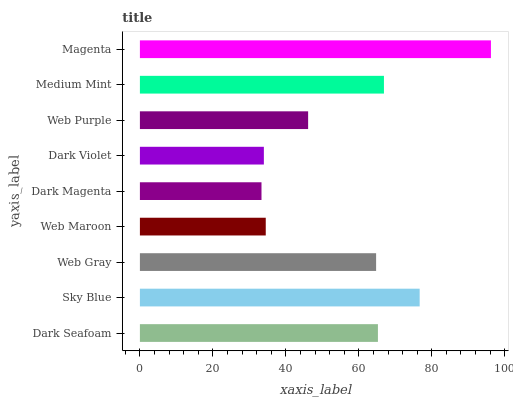Is Dark Magenta the minimum?
Answer yes or no. Yes. Is Magenta the maximum?
Answer yes or no. Yes. Is Sky Blue the minimum?
Answer yes or no. No. Is Sky Blue the maximum?
Answer yes or no. No. Is Sky Blue greater than Dark Seafoam?
Answer yes or no. Yes. Is Dark Seafoam less than Sky Blue?
Answer yes or no. Yes. Is Dark Seafoam greater than Sky Blue?
Answer yes or no. No. Is Sky Blue less than Dark Seafoam?
Answer yes or no. No. Is Web Gray the high median?
Answer yes or no. Yes. Is Web Gray the low median?
Answer yes or no. Yes. Is Dark Seafoam the high median?
Answer yes or no. No. Is Dark Violet the low median?
Answer yes or no. No. 